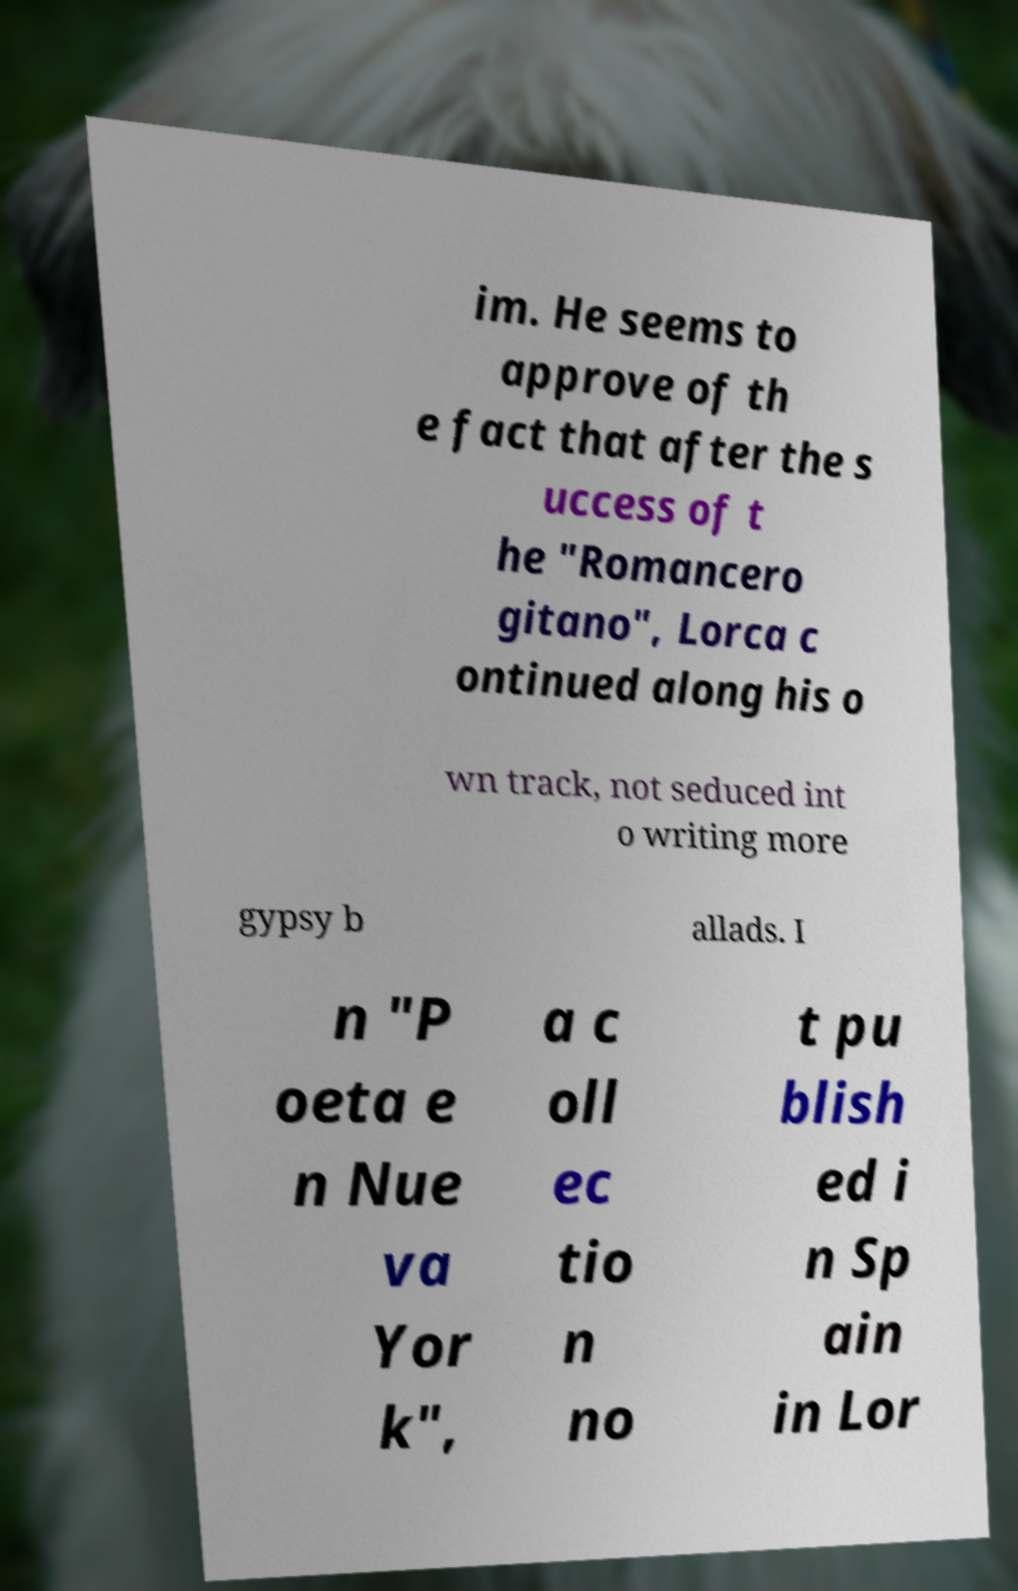There's text embedded in this image that I need extracted. Can you transcribe it verbatim? im. He seems to approve of th e fact that after the s uccess of t he "Romancero gitano", Lorca c ontinued along his o wn track, not seduced int o writing more gypsy b allads. I n "P oeta e n Nue va Yor k", a c oll ec tio n no t pu blish ed i n Sp ain in Lor 